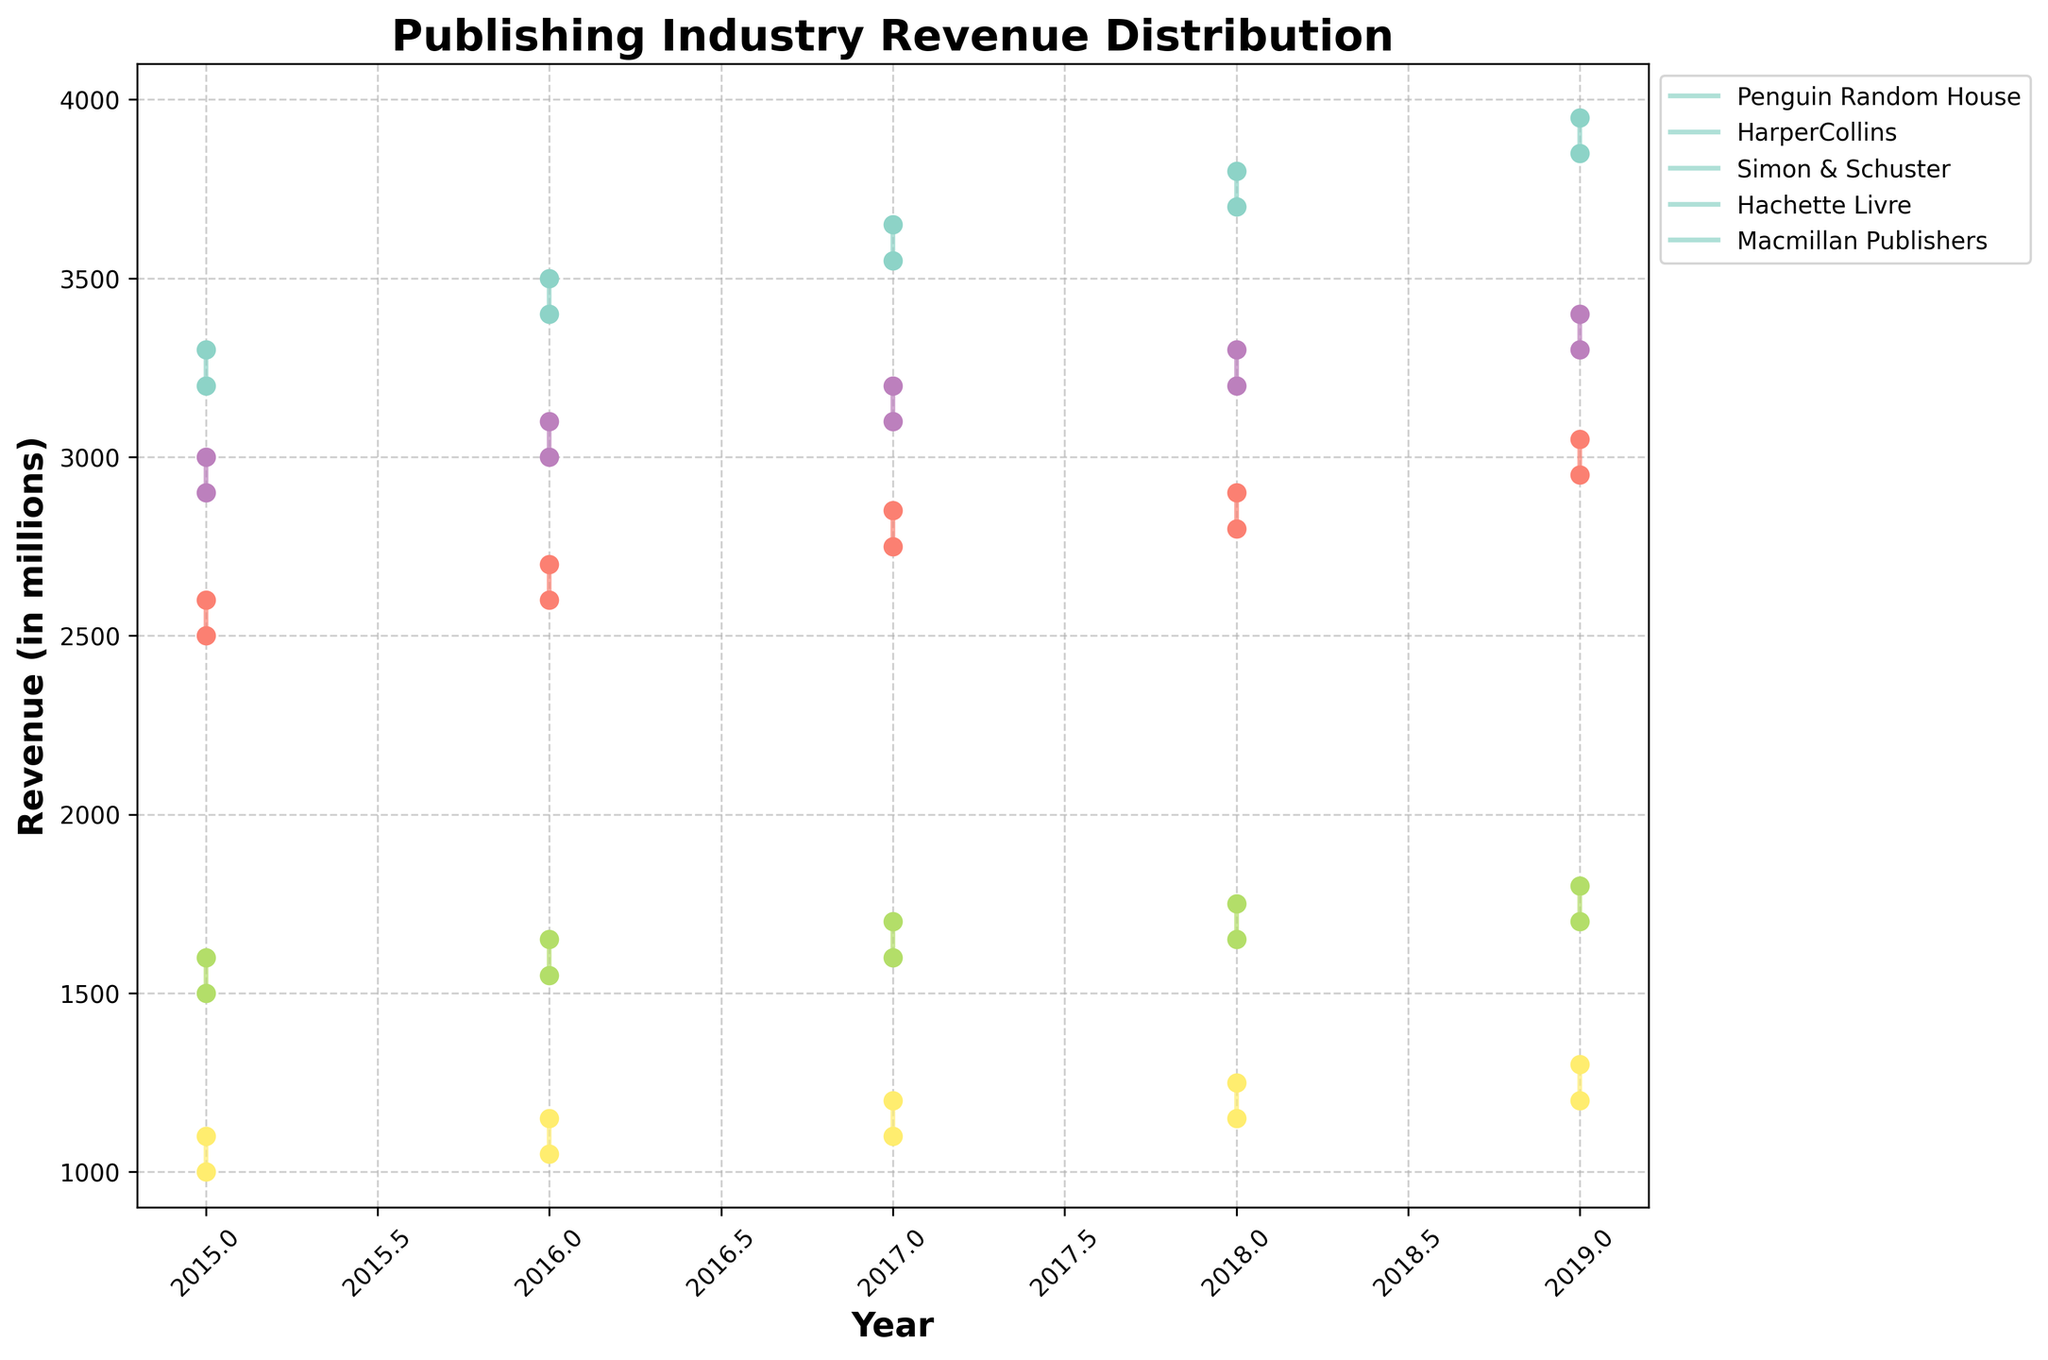What is the title of the figure? The title is typically located at the top of the chart and is bold and larger in font size compared to other text elements. The title of this chart is "Publishing Industry Revenue Distribution."
Answer: Publishing Industry Revenue Distribution Which publishing house had the highest revenue range in 2019? By looking at the endpoints of the revenue ranges for each publishing house in 2019, we can compare whose range is the highest. The highest range in 2019 is for Penguin Random House with a range from 3850 to 3950.
Answer: Penguin Random House How did the revenue range for HarperCollins change from 2015 to 2019? To assess the change, compare the minimum and maximum revenue values for HarperCollins in 2015 (2500-2600) to those in 2019 (2950-3050). Both the minimum and maximum revenue increased by 450 units each.
Answer: Increased by 450 units Which publishing house consistently had the lowest minimum revenue from 2015 to 2019? Reviewing the minimum revenue values across all years for each publishing house shows that Macmillan Publishers had the lowest minimum revenue each year ranging from 1000 to 1300.
Answer: Macmillan Publishers What is the average maximum revenue for Simon & Schuster over the 5 years? Calculate the average of the maximum revenue values for Simon & Schuster from 2015 to 2019: (1600 + 1650 + 1700 + 1750 + 1800) / 5 = 1700.
Answer: 1700 Which two publishing houses had revenue ranges that did not overlap in any year? Examine the revenue ranges for all the years. Simon & Schuster and Penguin Random House had ranges that did not overlap in any year because Simon & Schuster had much lower revenue ranges compared to Penguin Random House.
Answer: Simon & Schuster and Penguin Random House What is the trend in revenue range for Hachette Livre from 2015 to 2019? Review the changes in the minimum and maximum values for Hachette Livre each year. Both the minimum and maximum revenues show a steady increase from 2015 to 2019, indicating a consistent upward trend.
Answer: Upward trend In which year did Macmillan Publishers have the smallest revenue range, and what was the range? Determine which year Macmillan Publishers had the smallest gap between their minimum and maximum revenue values. The smallest range is in 2015 with a revenue range of 1000 to 1100, giving a range of 100.
Answer: 2015, 100 Between 2018 and 2019, which publishing house showed the greatest increase in both its minimum and maximum revenues? Compare the changes in both minimum and maximum revenues for each publishing house between these two years. HarperCollins had the greatest increase, with the minimum revenue increasing from 2800 to 2950 (by 150) and the maximum from 2900 to 3050 (by 150).
Answer: HarperCollins How does the revenue range of Hachette Livre in 2019 compare to that of Macmillan Publishers in the same year? In 2019, Hachette Livre has a revenue range of 3300 to 3400 (a range of 100), whereas Macmillan Publishers has a revenue range of 1200 to 1300 (also a range of 100).
Answer: Same range of 100 